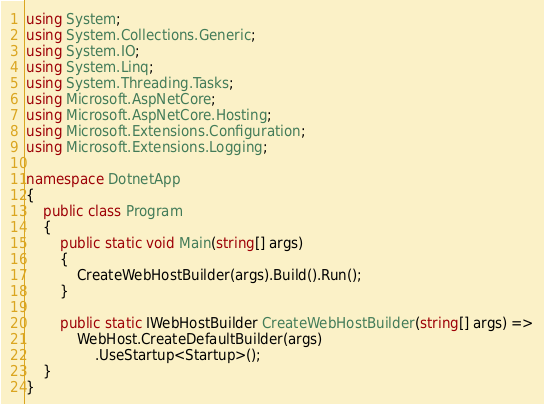Convert code to text. <code><loc_0><loc_0><loc_500><loc_500><_C#_>using System;
using System.Collections.Generic;
using System.IO;
using System.Linq;
using System.Threading.Tasks;
using Microsoft.AspNetCore;
using Microsoft.AspNetCore.Hosting;
using Microsoft.Extensions.Configuration;
using Microsoft.Extensions.Logging;

namespace DotnetApp
{
    public class Program
    {
        public static void Main(string[] args)
        {
            CreateWebHostBuilder(args).Build().Run();
        }

        public static IWebHostBuilder CreateWebHostBuilder(string[] args) =>
            WebHost.CreateDefaultBuilder(args)
                .UseStartup<Startup>();
    }
}
</code> 